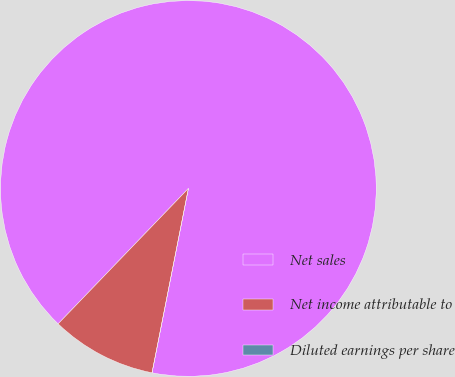<chart> <loc_0><loc_0><loc_500><loc_500><pie_chart><fcel>Net sales<fcel>Net income attributable to<fcel>Diluted earnings per share<nl><fcel>90.91%<fcel>9.09%<fcel>0.0%<nl></chart> 